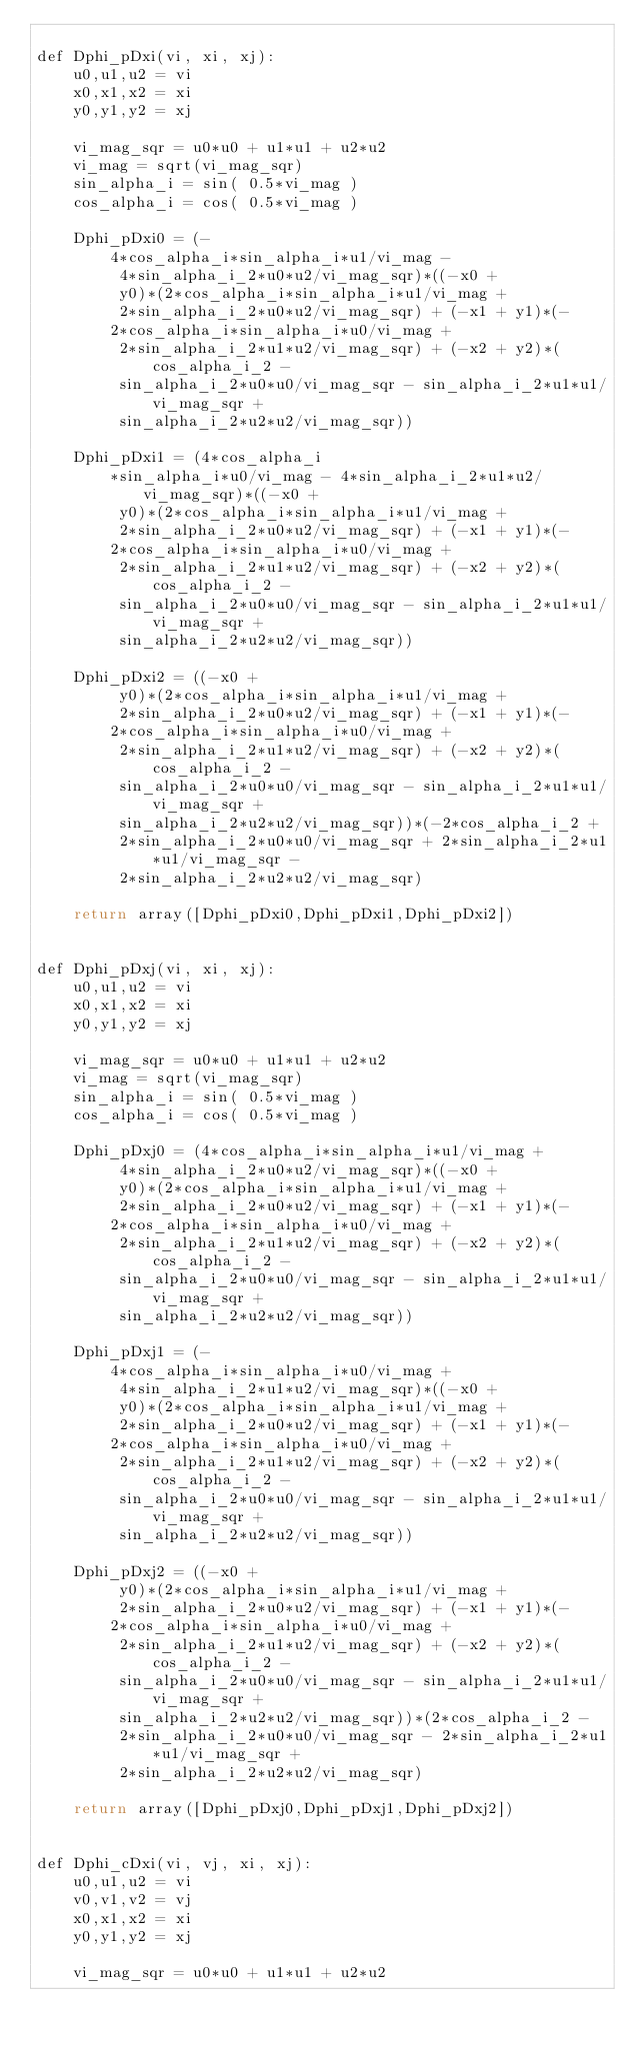<code> <loc_0><loc_0><loc_500><loc_500><_C++_>
def Dphi_pDxi(vi, xi, xj):
    u0,u1,u2 = vi
    x0,x1,x2 = xi
    y0,y1,y2 = xj
    
    vi_mag_sqr = u0*u0 + u1*u1 + u2*u2
    vi_mag = sqrt(vi_mag_sqr)
    sin_alpha_i = sin( 0.5*vi_mag )    
    cos_alpha_i = cos( 0.5*vi_mag )
        
    Dphi_pDxi0 = (-
        4*cos_alpha_i*sin_alpha_i*u1/vi_mag -
         4*sin_alpha_i_2*u0*u2/vi_mag_sqr)*((-x0 +
         y0)*(2*cos_alpha_i*sin_alpha_i*u1/vi_mag +
         2*sin_alpha_i_2*u0*u2/vi_mag_sqr) + (-x1 + y1)*(-
        2*cos_alpha_i*sin_alpha_i*u0/vi_mag +
         2*sin_alpha_i_2*u1*u2/vi_mag_sqr) + (-x2 + y2)*(cos_alpha_i_2 -
         sin_alpha_i_2*u0*u0/vi_mag_sqr - sin_alpha_i_2*u1*u1/vi_mag_sqr +
         sin_alpha_i_2*u2*u2/vi_mag_sqr))

    Dphi_pDxi1 = (4*cos_alpha_i
        *sin_alpha_i*u0/vi_mag - 4*sin_alpha_i_2*u1*u2/vi_mag_sqr)*((-x0 +
         y0)*(2*cos_alpha_i*sin_alpha_i*u1/vi_mag +
         2*sin_alpha_i_2*u0*u2/vi_mag_sqr) + (-x1 + y1)*(-
        2*cos_alpha_i*sin_alpha_i*u0/vi_mag +
         2*sin_alpha_i_2*u1*u2/vi_mag_sqr) + (-x2 + y2)*(cos_alpha_i_2 -
         sin_alpha_i_2*u0*u0/vi_mag_sqr - sin_alpha_i_2*u1*u1/vi_mag_sqr +
         sin_alpha_i_2*u2*u2/vi_mag_sqr))

    Dphi_pDxi2 = ((-x0 +
         y0)*(2*cos_alpha_i*sin_alpha_i*u1/vi_mag +
         2*sin_alpha_i_2*u0*u2/vi_mag_sqr) + (-x1 + y1)*(-
        2*cos_alpha_i*sin_alpha_i*u0/vi_mag +
         2*sin_alpha_i_2*u1*u2/vi_mag_sqr) + (-x2 + y2)*(cos_alpha_i_2 -
         sin_alpha_i_2*u0*u0/vi_mag_sqr - sin_alpha_i_2*u1*u1/vi_mag_sqr +
         sin_alpha_i_2*u2*u2/vi_mag_sqr))*(-2*cos_alpha_i_2 +
         2*sin_alpha_i_2*u0*u0/vi_mag_sqr + 2*sin_alpha_i_2*u1*u1/vi_mag_sqr -
         2*sin_alpha_i_2*u2*u2/vi_mag_sqr)
        
    return array([Dphi_pDxi0,Dphi_pDxi1,Dphi_pDxi2])


def Dphi_pDxj(vi, xi, xj):
    u0,u1,u2 = vi
    x0,x1,x2 = xi
    y0,y1,y2 = xj
    
    vi_mag_sqr = u0*u0 + u1*u1 + u2*u2
    vi_mag = sqrt(vi_mag_sqr)
    sin_alpha_i = sin( 0.5*vi_mag )    
    cos_alpha_i = cos( 0.5*vi_mag )
    
    Dphi_pDxj0 = (4*cos_alpha_i*sin_alpha_i*u1/vi_mag +
         4*sin_alpha_i_2*u0*u2/vi_mag_sqr)*((-x0 +
         y0)*(2*cos_alpha_i*sin_alpha_i*u1/vi_mag +
         2*sin_alpha_i_2*u0*u2/vi_mag_sqr) + (-x1 + y1)*(-
        2*cos_alpha_i*sin_alpha_i*u0/vi_mag +
         2*sin_alpha_i_2*u1*u2/vi_mag_sqr) + (-x2 + y2)*(cos_alpha_i_2 -
         sin_alpha_i_2*u0*u0/vi_mag_sqr - sin_alpha_i_2*u1*u1/vi_mag_sqr +
         sin_alpha_i_2*u2*u2/vi_mag_sqr))

    Dphi_pDxj1 = (-
        4*cos_alpha_i*sin_alpha_i*u0/vi_mag +
         4*sin_alpha_i_2*u1*u2/vi_mag_sqr)*((-x0 +
         y0)*(2*cos_alpha_i*sin_alpha_i*u1/vi_mag +
         2*sin_alpha_i_2*u0*u2/vi_mag_sqr) + (-x1 + y1)*(-
        2*cos_alpha_i*sin_alpha_i*u0/vi_mag +
         2*sin_alpha_i_2*u1*u2/vi_mag_sqr) + (-x2 + y2)*(cos_alpha_i_2 -
         sin_alpha_i_2*u0*u0/vi_mag_sqr - sin_alpha_i_2*u1*u1/vi_mag_sqr +
         sin_alpha_i_2*u2*u2/vi_mag_sqr))

    Dphi_pDxj2 = ((-x0 +
         y0)*(2*cos_alpha_i*sin_alpha_i*u1/vi_mag +
         2*sin_alpha_i_2*u0*u2/vi_mag_sqr) + (-x1 + y1)*(-
        2*cos_alpha_i*sin_alpha_i*u0/vi_mag +
         2*sin_alpha_i_2*u1*u2/vi_mag_sqr) + (-x2 + y2)*(cos_alpha_i_2 -
         sin_alpha_i_2*u0*u0/vi_mag_sqr - sin_alpha_i_2*u1*u1/vi_mag_sqr +
         sin_alpha_i_2*u2*u2/vi_mag_sqr))*(2*cos_alpha_i_2 -
         2*sin_alpha_i_2*u0*u0/vi_mag_sqr - 2*sin_alpha_i_2*u1*u1/vi_mag_sqr +
         2*sin_alpha_i_2*u2*u2/vi_mag_sqr)

    return array([Dphi_pDxj0,Dphi_pDxj1,Dphi_pDxj2])


def Dphi_cDxi(vi, vj, xi, xj):
    u0,u1,u2 = vi
    v0,v1,v2 = vj
    x0,x1,x2 = xi
    y0,y1,y2 = xj
    
    vi_mag_sqr = u0*u0 + u1*u1 + u2*u2</code> 